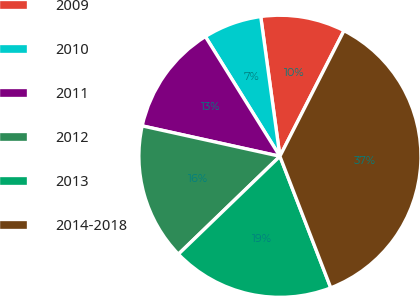<chart> <loc_0><loc_0><loc_500><loc_500><pie_chart><fcel>2009<fcel>2010<fcel>2011<fcel>2012<fcel>2013<fcel>2014-2018<nl><fcel>9.68%<fcel>6.69%<fcel>12.68%<fcel>15.67%<fcel>18.66%<fcel>36.62%<nl></chart> 